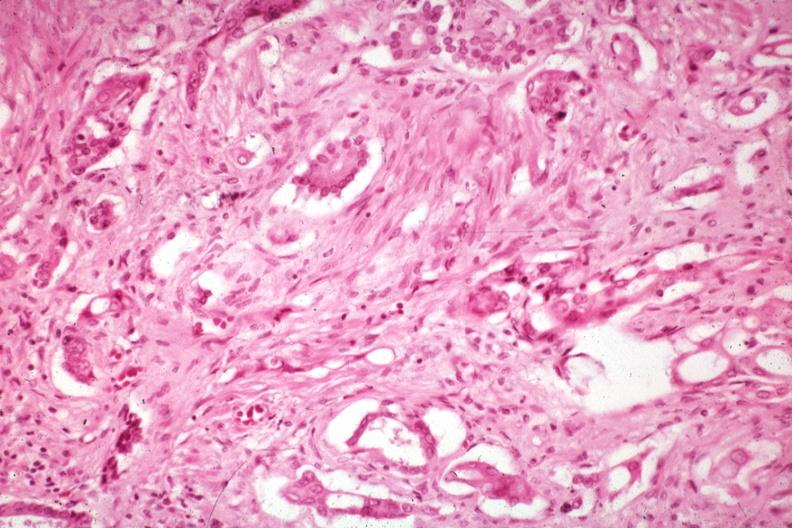re anaplastic carcinoma with desmoplasia large myofibroblastic cell prominent in the stroma?
Answer the question using a single word or phrase. Yes 